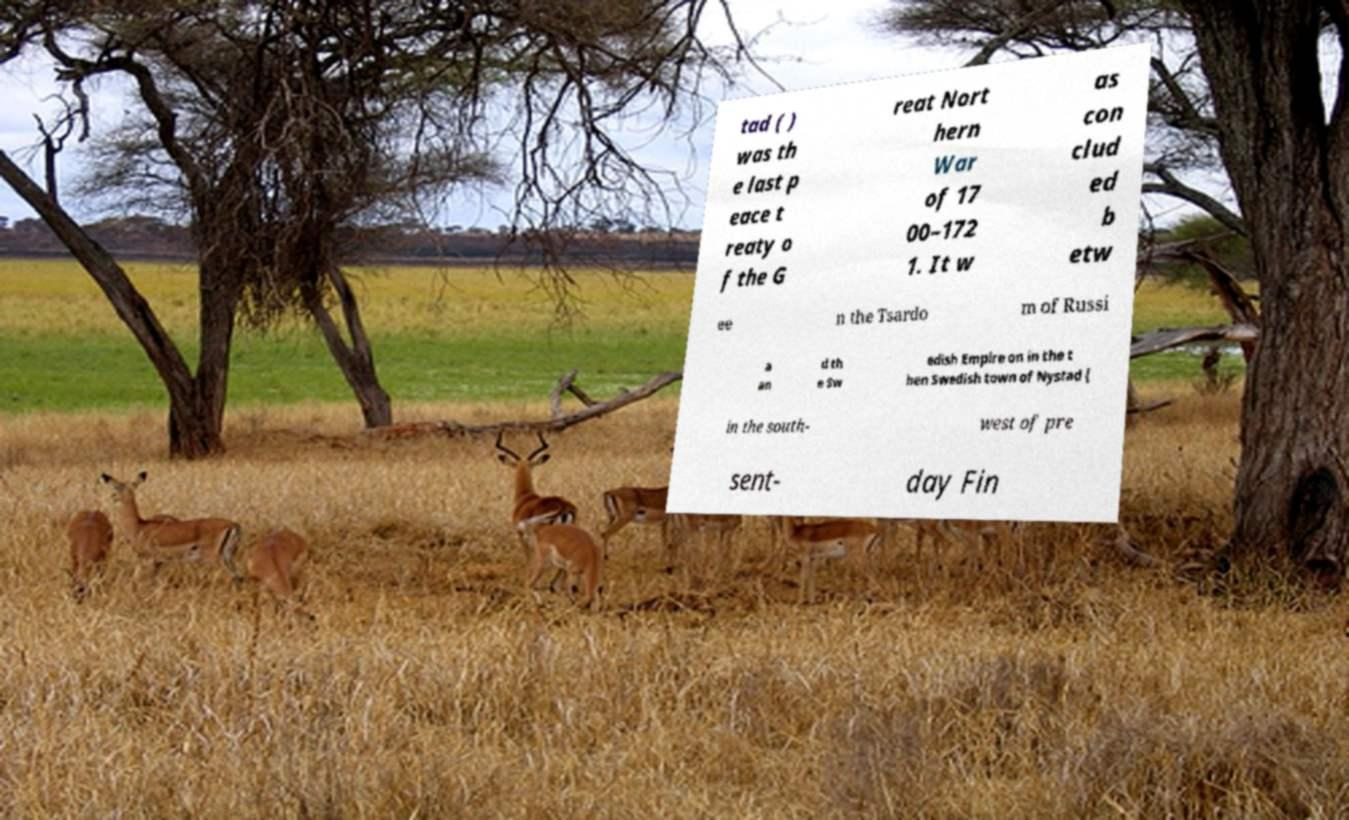For documentation purposes, I need the text within this image transcribed. Could you provide that? tad ( ) was th e last p eace t reaty o f the G reat Nort hern War of 17 00–172 1. It w as con clud ed b etw ee n the Tsardo m of Russi a an d th e Sw edish Empire on in the t hen Swedish town of Nystad ( in the south- west of pre sent- day Fin 